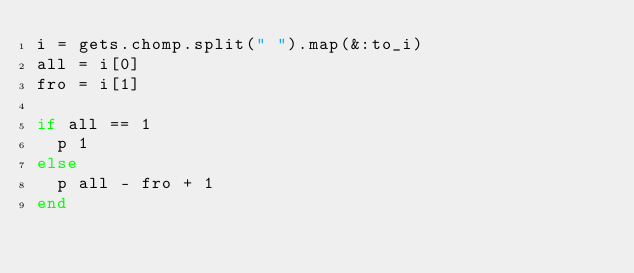<code> <loc_0><loc_0><loc_500><loc_500><_Ruby_>i = gets.chomp.split(" ").map(&:to_i)
all = i[0]
fro = i[1]

if all == 1
  p 1
else
  p all - fro + 1
end
</code> 